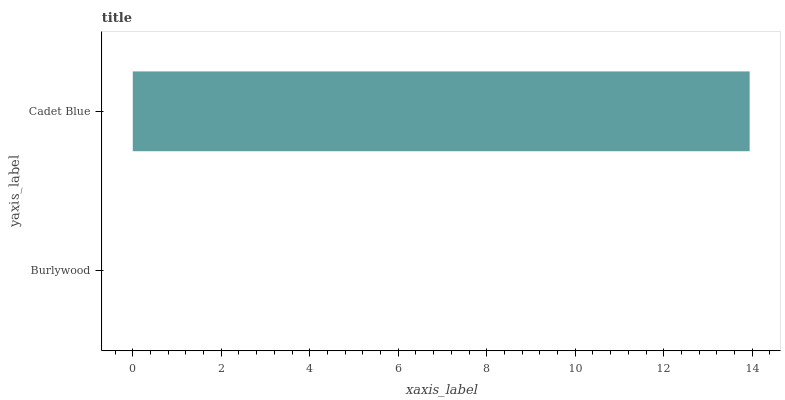Is Burlywood the minimum?
Answer yes or no. Yes. Is Cadet Blue the maximum?
Answer yes or no. Yes. Is Cadet Blue the minimum?
Answer yes or no. No. Is Cadet Blue greater than Burlywood?
Answer yes or no. Yes. Is Burlywood less than Cadet Blue?
Answer yes or no. Yes. Is Burlywood greater than Cadet Blue?
Answer yes or no. No. Is Cadet Blue less than Burlywood?
Answer yes or no. No. Is Cadet Blue the high median?
Answer yes or no. Yes. Is Burlywood the low median?
Answer yes or no. Yes. Is Burlywood the high median?
Answer yes or no. No. Is Cadet Blue the low median?
Answer yes or no. No. 